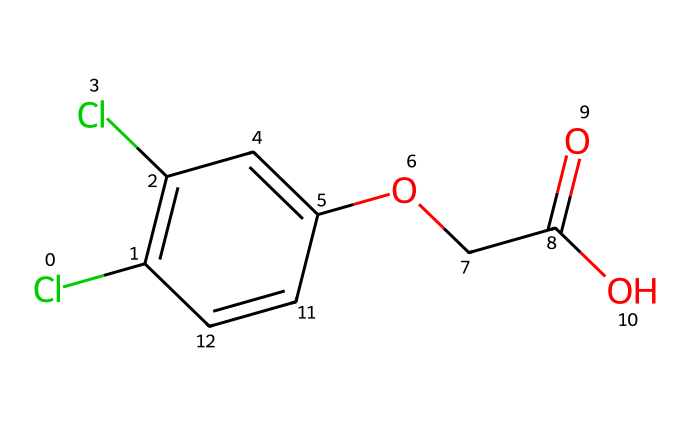What is the molecular formula of 2,4-D? To determine the molecular formula, we can identify the different elements present in the SMILES representation. Examining the structure, we find two chlorine (Cl) atoms, 9 carbon (C) atoms, 9 hydrogen (H) atoms, and 4 oxygen (O) atoms. The molecular formula can be compiled as C8H6Cl2O3.
Answer: C8H6Cl2O3 How many carbon atoms are present in 2,4-D? By analyzing the SMILES structure, we can count all the carbon (C) atoms involved. There are a total of 8 carbon atoms visible in the structure.
Answer: 8 What functional groups are present in 2,4-D? In the structure, we identify significant functional groups: a carboxylic acid group (-COOH), an ester group (-O-), and a phenolic hydroxyl group (-OH). This shows that 2,4-D contains these distinct functional groups.
Answer: carboxylic acid, ester, hydroxyl What effect does the chlorination have on the herbicidal activity of 2,4-D? The chlorination introduces electronegative chlorine atoms, enhancing the herbicidal activity by increasing the lipophilicity and reducing metabolic degradation in plants. This structural modification contributes to the efficacy of 2,4-D as a selective herbicide.
Answer: increases activity In which crops is 2,4-D commonly used? 2,4-D is primarily utilized in various broadleaf crops such as wheat, maize, and turfgrass. It serves as a selective herbicide to control weed growth without harming the crops.
Answer: wheat, maize, turfgrass What are the potential environmental concerns associated with 2,4-D usage? The use of 2,4-D can lead to environmental concerns such as water contamination and non-target organism toxicity. Residues may persist in soil and affect surrounding flora and fauna if not managed properly.
Answer: water contamination, toxicity Which type of herbicide is 2,4-D classified as? 2,4-D is classified as a synthetic auxin, which mimics natural plant hormones to regulate plant growth processes and manage weed populations effectively.
Answer: synthetic auxin 